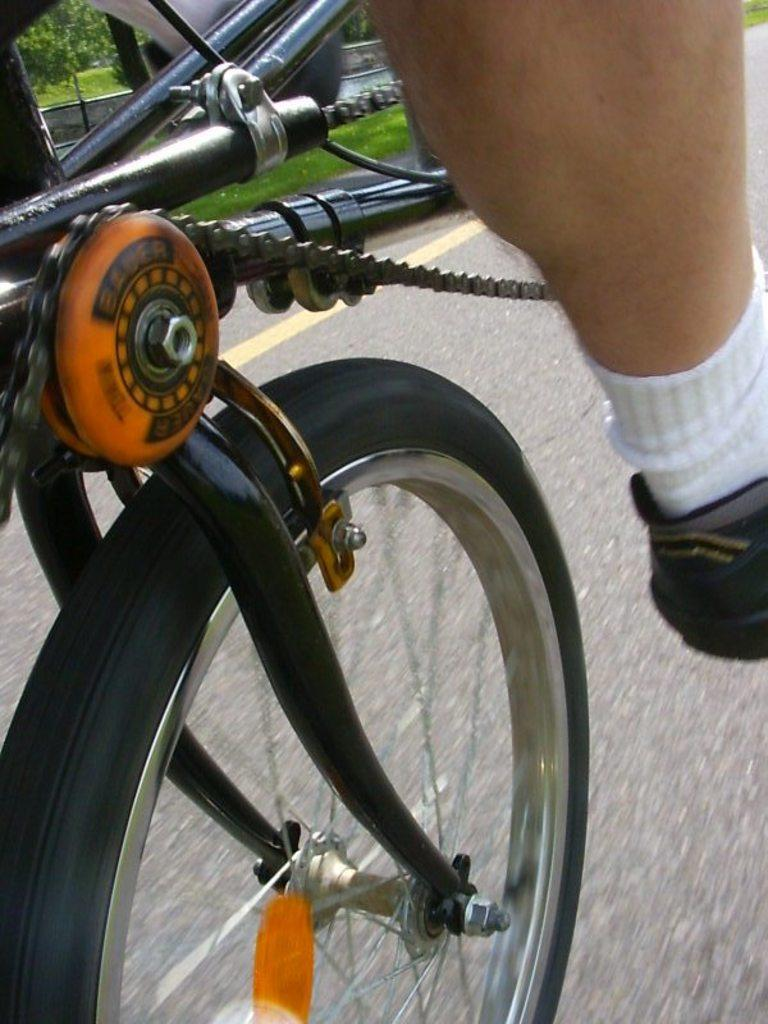What mechanical component can be seen in the image? There is a wheel in the image. What other mechanical component is present in the image? There is a rod in the image. Is there any connecting element between the wheel and the rod? Yes, there is a chain in the image. Can you describe the person in the image? The person's leg is visible in the only visible part of their body in the image, and they are wearing shoes and socks. What type of fire can be seen in the image? There is no fire present in the image. What impulse might the person have to interact with the mechanical components in the image? The image does not provide information about the person's impulses or intentions, so we cannot determine their motivation for interacting with the mechanical components. 